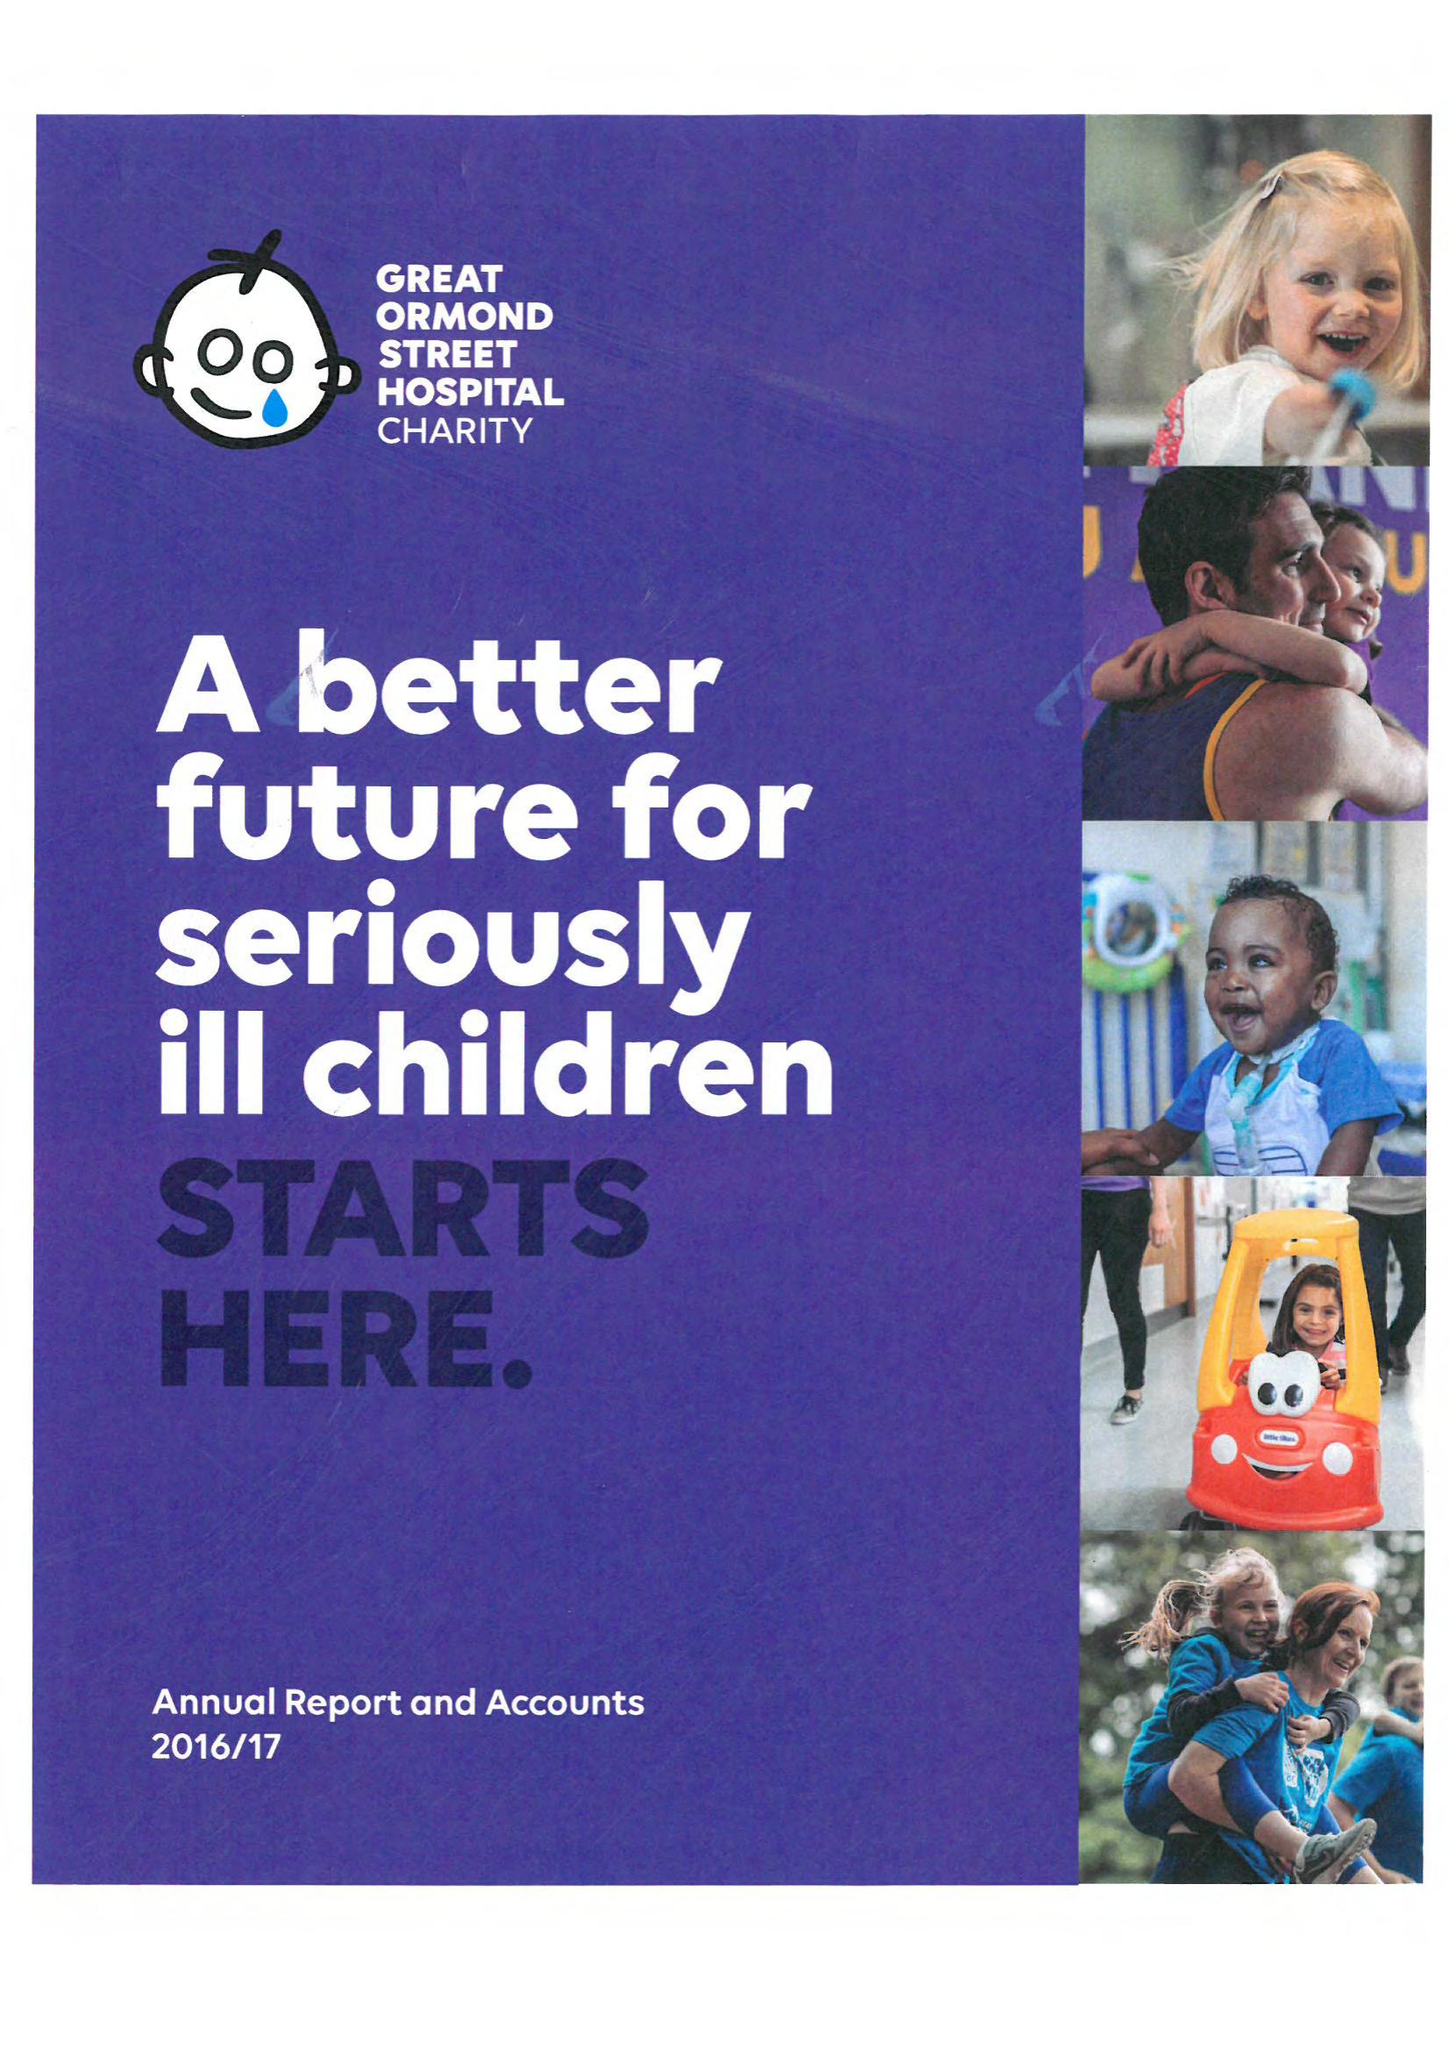What is the value for the income_annually_in_british_pounds?
Answer the question using a single word or phrase. 93290056.00 